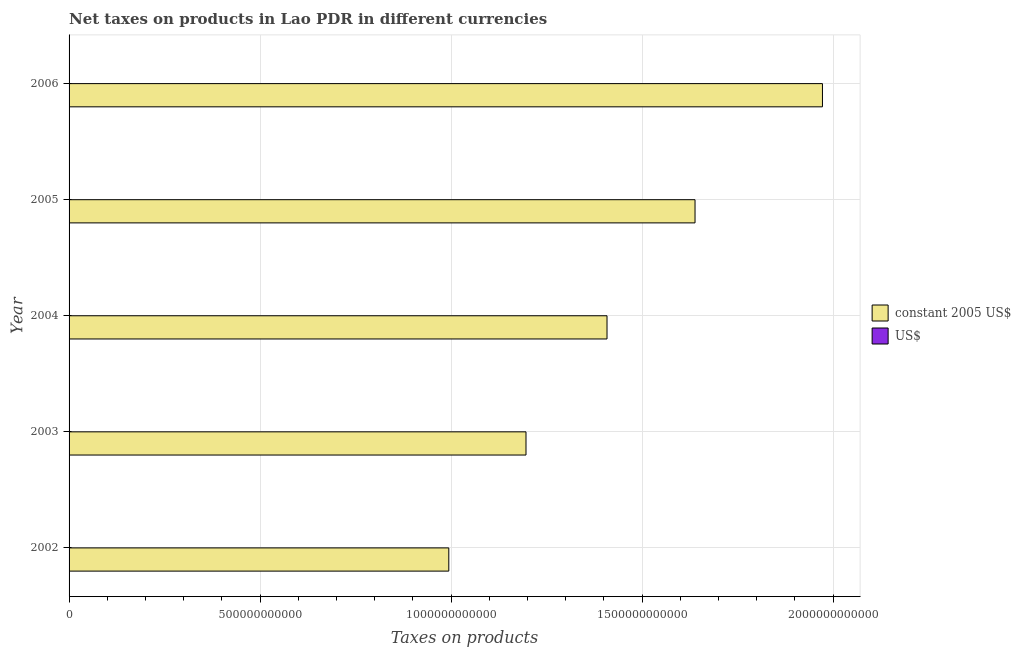How many different coloured bars are there?
Offer a terse response. 2. How many groups of bars are there?
Provide a short and direct response. 5. Are the number of bars per tick equal to the number of legend labels?
Your response must be concise. Yes. Are the number of bars on each tick of the Y-axis equal?
Provide a succinct answer. Yes. What is the label of the 1st group of bars from the top?
Offer a very short reply. 2006. In how many cases, is the number of bars for a given year not equal to the number of legend labels?
Make the answer very short. 0. What is the net taxes in us$ in 2002?
Provide a succinct answer. 9.89e+07. Across all years, what is the maximum net taxes in us$?
Offer a terse response. 1.94e+08. Across all years, what is the minimum net taxes in constant 2005 us$?
Make the answer very short. 9.94e+11. In which year was the net taxes in constant 2005 us$ maximum?
Keep it short and to the point. 2006. In which year was the net taxes in us$ minimum?
Offer a very short reply. 2002. What is the total net taxes in us$ in the graph?
Offer a very short reply. 6.94e+08. What is the difference between the net taxes in constant 2005 us$ in 2002 and that in 2004?
Offer a terse response. -4.14e+11. What is the difference between the net taxes in constant 2005 us$ in 2002 and the net taxes in us$ in 2005?
Make the answer very short. 9.94e+11. What is the average net taxes in us$ per year?
Make the answer very short. 1.39e+08. In the year 2006, what is the difference between the net taxes in constant 2005 us$ and net taxes in us$?
Your response must be concise. 1.97e+12. In how many years, is the net taxes in us$ greater than 1000000000000 units?
Provide a succinct answer. 0. What is the ratio of the net taxes in us$ in 2002 to that in 2004?
Make the answer very short. 0.74. Is the net taxes in us$ in 2005 less than that in 2006?
Provide a short and direct response. Yes. What is the difference between the highest and the second highest net taxes in constant 2005 us$?
Give a very brief answer. 3.34e+11. What is the difference between the highest and the lowest net taxes in constant 2005 us$?
Your response must be concise. 9.78e+11. Is the sum of the net taxes in constant 2005 us$ in 2002 and 2003 greater than the maximum net taxes in us$ across all years?
Your answer should be compact. Yes. What does the 1st bar from the top in 2002 represents?
Provide a short and direct response. US$. What does the 2nd bar from the bottom in 2004 represents?
Give a very brief answer. US$. Are all the bars in the graph horizontal?
Ensure brevity in your answer.  Yes. What is the difference between two consecutive major ticks on the X-axis?
Your answer should be compact. 5.00e+11. Are the values on the major ticks of X-axis written in scientific E-notation?
Your answer should be compact. No. Does the graph contain any zero values?
Keep it short and to the point. No. Does the graph contain grids?
Give a very brief answer. Yes. Where does the legend appear in the graph?
Provide a succinct answer. Center right. How many legend labels are there?
Offer a terse response. 2. How are the legend labels stacked?
Make the answer very short. Vertical. What is the title of the graph?
Give a very brief answer. Net taxes on products in Lao PDR in different currencies. What is the label or title of the X-axis?
Offer a very short reply. Taxes on products. What is the Taxes on products in constant 2005 US$ in 2002?
Ensure brevity in your answer.  9.94e+11. What is the Taxes on products of US$ in 2002?
Your answer should be very brief. 9.89e+07. What is the Taxes on products of constant 2005 US$ in 2003?
Give a very brief answer. 1.20e+12. What is the Taxes on products in US$ in 2003?
Your answer should be compact. 1.14e+08. What is the Taxes on products in constant 2005 US$ in 2004?
Offer a very short reply. 1.41e+12. What is the Taxes on products in US$ in 2004?
Give a very brief answer. 1.33e+08. What is the Taxes on products of constant 2005 US$ in 2005?
Your response must be concise. 1.64e+12. What is the Taxes on products of US$ in 2005?
Provide a succinct answer. 1.54e+08. What is the Taxes on products in constant 2005 US$ in 2006?
Your answer should be very brief. 1.97e+12. What is the Taxes on products of US$ in 2006?
Provide a short and direct response. 1.94e+08. Across all years, what is the maximum Taxes on products in constant 2005 US$?
Your response must be concise. 1.97e+12. Across all years, what is the maximum Taxes on products of US$?
Offer a terse response. 1.94e+08. Across all years, what is the minimum Taxes on products of constant 2005 US$?
Your answer should be compact. 9.94e+11. Across all years, what is the minimum Taxes on products of US$?
Ensure brevity in your answer.  9.89e+07. What is the total Taxes on products of constant 2005 US$ in the graph?
Keep it short and to the point. 7.21e+12. What is the total Taxes on products in US$ in the graph?
Ensure brevity in your answer.  6.94e+08. What is the difference between the Taxes on products of constant 2005 US$ in 2002 and that in 2003?
Your answer should be compact. -2.02e+11. What is the difference between the Taxes on products in US$ in 2002 and that in 2003?
Provide a succinct answer. -1.49e+07. What is the difference between the Taxes on products in constant 2005 US$ in 2002 and that in 2004?
Ensure brevity in your answer.  -4.14e+11. What is the difference between the Taxes on products of US$ in 2002 and that in 2004?
Give a very brief answer. -3.42e+07. What is the difference between the Taxes on products of constant 2005 US$ in 2002 and that in 2005?
Ensure brevity in your answer.  -6.45e+11. What is the difference between the Taxes on products in US$ in 2002 and that in 2005?
Keep it short and to the point. -5.50e+07. What is the difference between the Taxes on products in constant 2005 US$ in 2002 and that in 2006?
Offer a terse response. -9.78e+11. What is the difference between the Taxes on products of US$ in 2002 and that in 2006?
Offer a terse response. -9.53e+07. What is the difference between the Taxes on products of constant 2005 US$ in 2003 and that in 2004?
Your answer should be compact. -2.12e+11. What is the difference between the Taxes on products in US$ in 2003 and that in 2004?
Provide a short and direct response. -1.93e+07. What is the difference between the Taxes on products in constant 2005 US$ in 2003 and that in 2005?
Offer a terse response. -4.43e+11. What is the difference between the Taxes on products of US$ in 2003 and that in 2005?
Provide a short and direct response. -4.00e+07. What is the difference between the Taxes on products of constant 2005 US$ in 2003 and that in 2006?
Provide a short and direct response. -7.76e+11. What is the difference between the Taxes on products of US$ in 2003 and that in 2006?
Offer a terse response. -8.04e+07. What is the difference between the Taxes on products in constant 2005 US$ in 2004 and that in 2005?
Provide a short and direct response. -2.30e+11. What is the difference between the Taxes on products in US$ in 2004 and that in 2005?
Your answer should be compact. -2.08e+07. What is the difference between the Taxes on products of constant 2005 US$ in 2004 and that in 2006?
Provide a short and direct response. -5.64e+11. What is the difference between the Taxes on products in US$ in 2004 and that in 2006?
Offer a very short reply. -6.11e+07. What is the difference between the Taxes on products in constant 2005 US$ in 2005 and that in 2006?
Provide a short and direct response. -3.34e+11. What is the difference between the Taxes on products of US$ in 2005 and that in 2006?
Your response must be concise. -4.03e+07. What is the difference between the Taxes on products in constant 2005 US$ in 2002 and the Taxes on products in US$ in 2003?
Provide a short and direct response. 9.94e+11. What is the difference between the Taxes on products of constant 2005 US$ in 2002 and the Taxes on products of US$ in 2004?
Provide a succinct answer. 9.94e+11. What is the difference between the Taxes on products in constant 2005 US$ in 2002 and the Taxes on products in US$ in 2005?
Offer a very short reply. 9.94e+11. What is the difference between the Taxes on products of constant 2005 US$ in 2002 and the Taxes on products of US$ in 2006?
Your answer should be compact. 9.94e+11. What is the difference between the Taxes on products in constant 2005 US$ in 2003 and the Taxes on products in US$ in 2004?
Offer a very short reply. 1.20e+12. What is the difference between the Taxes on products of constant 2005 US$ in 2003 and the Taxes on products of US$ in 2005?
Your answer should be very brief. 1.20e+12. What is the difference between the Taxes on products of constant 2005 US$ in 2003 and the Taxes on products of US$ in 2006?
Offer a very short reply. 1.20e+12. What is the difference between the Taxes on products in constant 2005 US$ in 2004 and the Taxes on products in US$ in 2005?
Your answer should be very brief. 1.41e+12. What is the difference between the Taxes on products in constant 2005 US$ in 2004 and the Taxes on products in US$ in 2006?
Make the answer very short. 1.41e+12. What is the difference between the Taxes on products of constant 2005 US$ in 2005 and the Taxes on products of US$ in 2006?
Your response must be concise. 1.64e+12. What is the average Taxes on products of constant 2005 US$ per year?
Your response must be concise. 1.44e+12. What is the average Taxes on products of US$ per year?
Your answer should be very brief. 1.39e+08. In the year 2002, what is the difference between the Taxes on products in constant 2005 US$ and Taxes on products in US$?
Ensure brevity in your answer.  9.94e+11. In the year 2003, what is the difference between the Taxes on products in constant 2005 US$ and Taxes on products in US$?
Your answer should be compact. 1.20e+12. In the year 2004, what is the difference between the Taxes on products of constant 2005 US$ and Taxes on products of US$?
Provide a succinct answer. 1.41e+12. In the year 2005, what is the difference between the Taxes on products in constant 2005 US$ and Taxes on products in US$?
Give a very brief answer. 1.64e+12. In the year 2006, what is the difference between the Taxes on products of constant 2005 US$ and Taxes on products of US$?
Offer a very short reply. 1.97e+12. What is the ratio of the Taxes on products in constant 2005 US$ in 2002 to that in 2003?
Your answer should be very brief. 0.83. What is the ratio of the Taxes on products in US$ in 2002 to that in 2003?
Keep it short and to the point. 0.87. What is the ratio of the Taxes on products of constant 2005 US$ in 2002 to that in 2004?
Provide a short and direct response. 0.71. What is the ratio of the Taxes on products of US$ in 2002 to that in 2004?
Ensure brevity in your answer.  0.74. What is the ratio of the Taxes on products in constant 2005 US$ in 2002 to that in 2005?
Your answer should be very brief. 0.61. What is the ratio of the Taxes on products of US$ in 2002 to that in 2005?
Your answer should be very brief. 0.64. What is the ratio of the Taxes on products of constant 2005 US$ in 2002 to that in 2006?
Your answer should be compact. 0.5. What is the ratio of the Taxes on products in US$ in 2002 to that in 2006?
Give a very brief answer. 0.51. What is the ratio of the Taxes on products of constant 2005 US$ in 2003 to that in 2004?
Offer a terse response. 0.85. What is the ratio of the Taxes on products of US$ in 2003 to that in 2004?
Your response must be concise. 0.85. What is the ratio of the Taxes on products in constant 2005 US$ in 2003 to that in 2005?
Make the answer very short. 0.73. What is the ratio of the Taxes on products in US$ in 2003 to that in 2005?
Provide a succinct answer. 0.74. What is the ratio of the Taxes on products of constant 2005 US$ in 2003 to that in 2006?
Ensure brevity in your answer.  0.61. What is the ratio of the Taxes on products of US$ in 2003 to that in 2006?
Offer a terse response. 0.59. What is the ratio of the Taxes on products of constant 2005 US$ in 2004 to that in 2005?
Your answer should be very brief. 0.86. What is the ratio of the Taxes on products in US$ in 2004 to that in 2005?
Your answer should be compact. 0.87. What is the ratio of the Taxes on products in constant 2005 US$ in 2004 to that in 2006?
Make the answer very short. 0.71. What is the ratio of the Taxes on products of US$ in 2004 to that in 2006?
Provide a short and direct response. 0.69. What is the ratio of the Taxes on products of constant 2005 US$ in 2005 to that in 2006?
Provide a succinct answer. 0.83. What is the ratio of the Taxes on products of US$ in 2005 to that in 2006?
Provide a succinct answer. 0.79. What is the difference between the highest and the second highest Taxes on products of constant 2005 US$?
Give a very brief answer. 3.34e+11. What is the difference between the highest and the second highest Taxes on products of US$?
Offer a very short reply. 4.03e+07. What is the difference between the highest and the lowest Taxes on products of constant 2005 US$?
Your answer should be very brief. 9.78e+11. What is the difference between the highest and the lowest Taxes on products in US$?
Keep it short and to the point. 9.53e+07. 